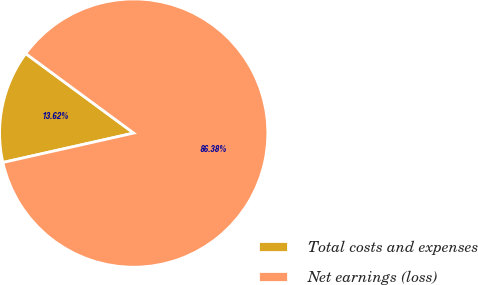Convert chart. <chart><loc_0><loc_0><loc_500><loc_500><pie_chart><fcel>Total costs and expenses<fcel>Net earnings (loss)<nl><fcel>13.62%<fcel>86.38%<nl></chart> 